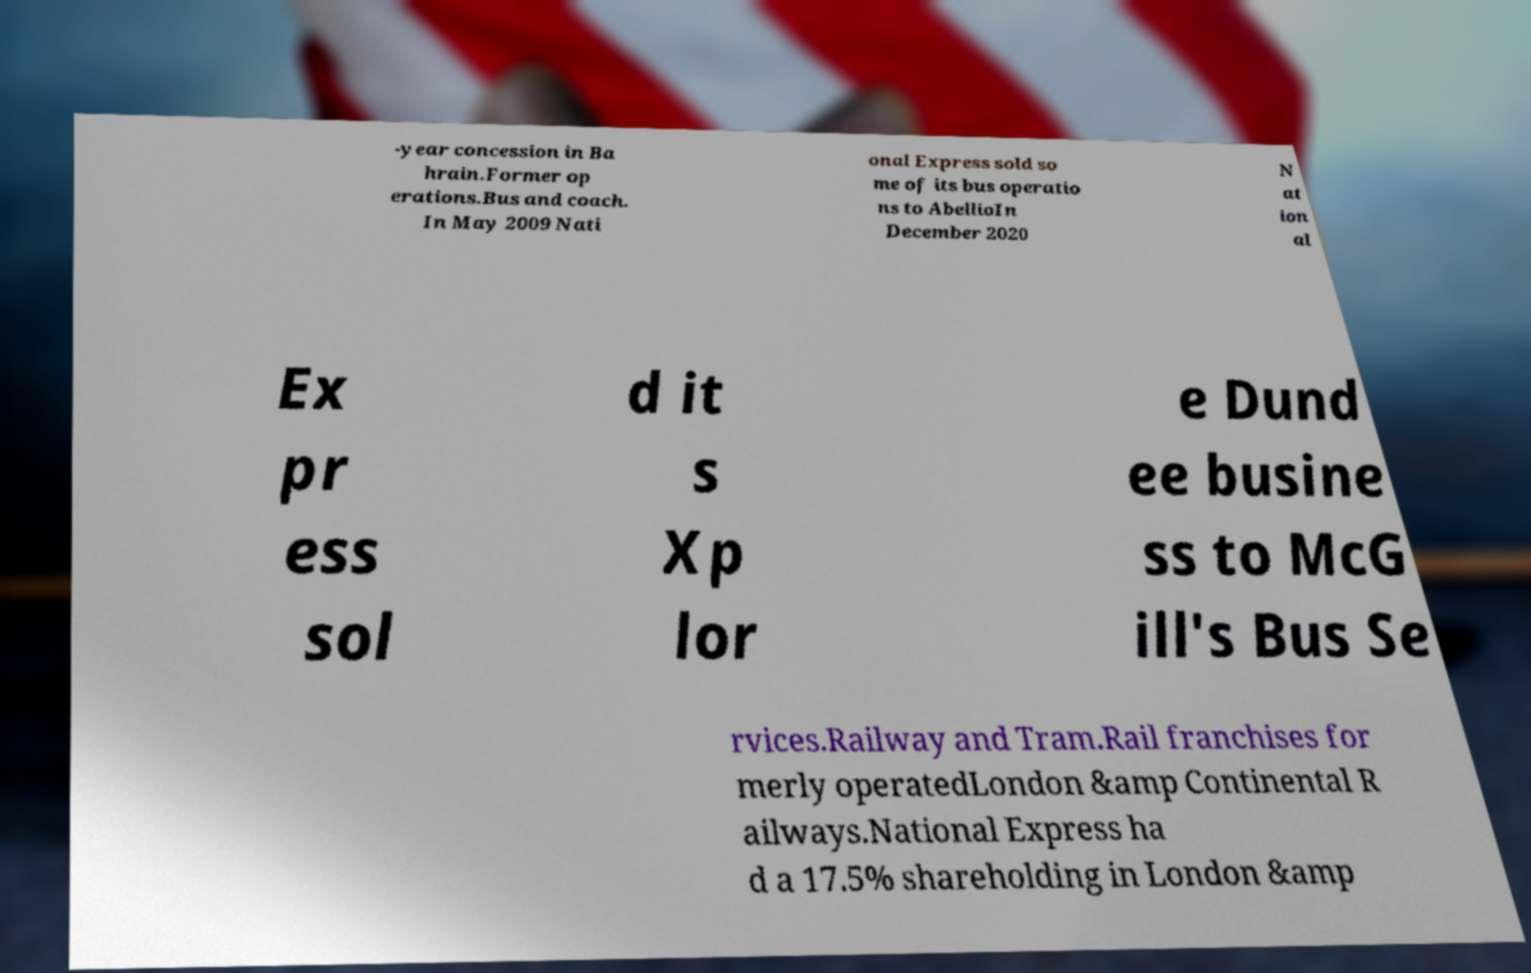Please read and relay the text visible in this image. What does it say? -year concession in Ba hrain.Former op erations.Bus and coach. In May 2009 Nati onal Express sold so me of its bus operatio ns to AbellioIn December 2020 N at ion al Ex pr ess sol d it s Xp lor e Dund ee busine ss to McG ill's Bus Se rvices.Railway and Tram.Rail franchises for merly operatedLondon &amp Continental R ailways.National Express ha d a 17.5% shareholding in London &amp 